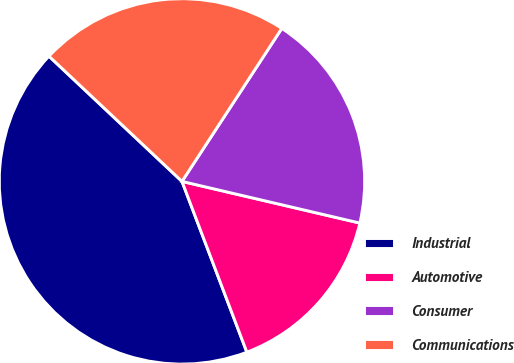Convert chart. <chart><loc_0><loc_0><loc_500><loc_500><pie_chart><fcel>Industrial<fcel>Automotive<fcel>Consumer<fcel>Communications<nl><fcel>42.8%<fcel>15.56%<fcel>19.46%<fcel>22.18%<nl></chart> 